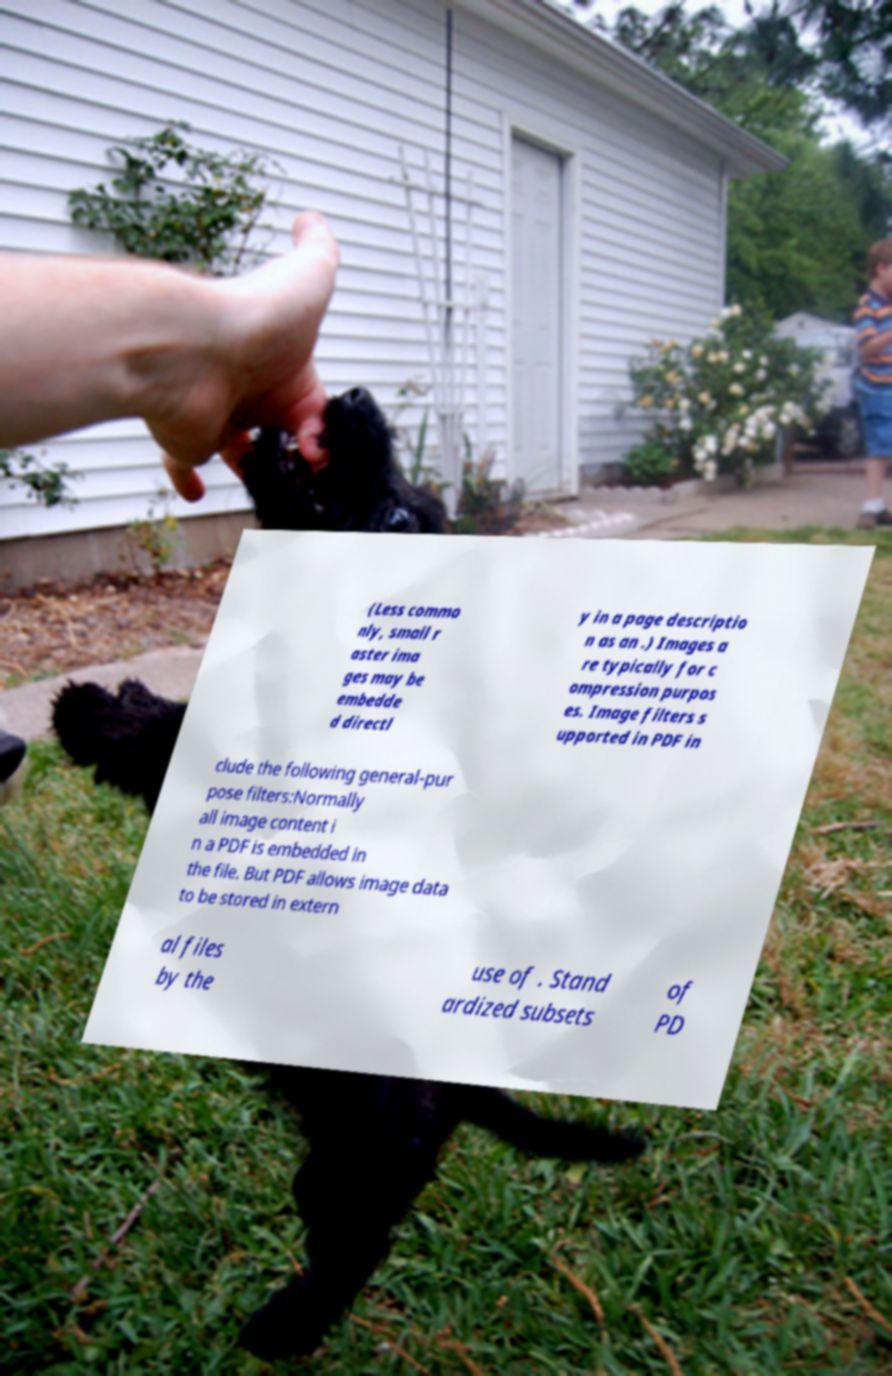Can you read and provide the text displayed in the image?This photo seems to have some interesting text. Can you extract and type it out for me? (Less commo nly, small r aster ima ges may be embedde d directl y in a page descriptio n as an .) Images a re typically for c ompression purpos es. Image filters s upported in PDF in clude the following general-pur pose filters:Normally all image content i n a PDF is embedded in the file. But PDF allows image data to be stored in extern al files by the use of . Stand ardized subsets of PD 